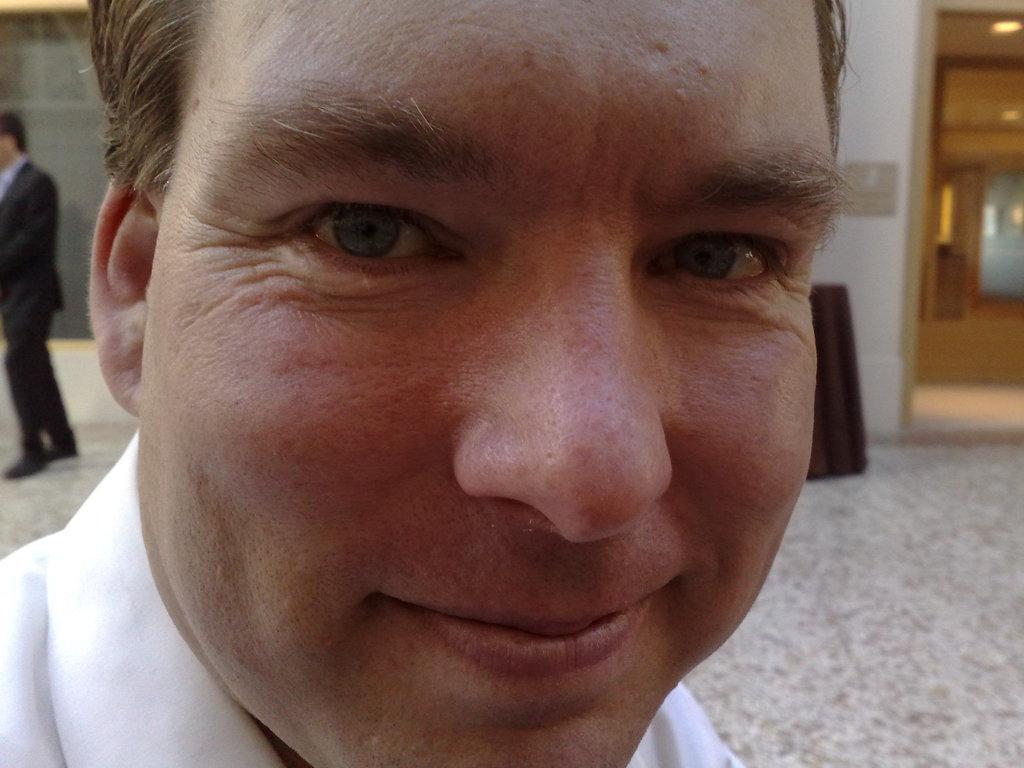How would you summarize this image in a sentence or two? In this picture we can see a man, he is smiling and in the background we can see a person, wall, lights and some objects. 